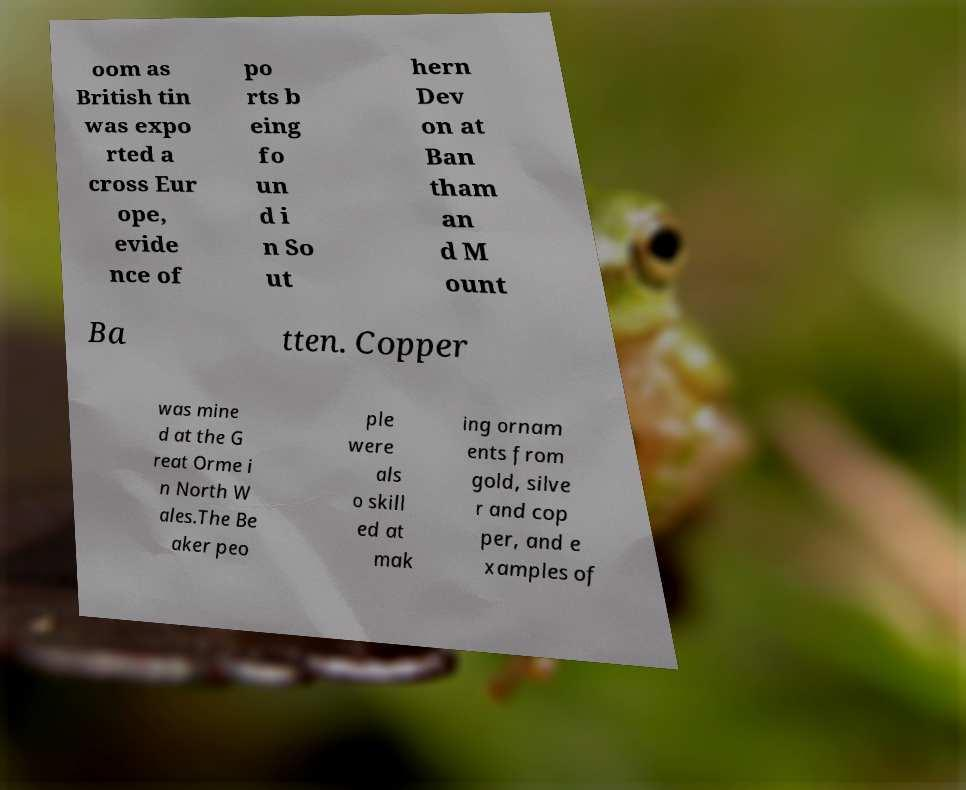There's text embedded in this image that I need extracted. Can you transcribe it verbatim? oom as British tin was expo rted a cross Eur ope, evide nce of po rts b eing fo un d i n So ut hern Dev on at Ban tham an d M ount Ba tten. Copper was mine d at the G reat Orme i n North W ales.The Be aker peo ple were als o skill ed at mak ing ornam ents from gold, silve r and cop per, and e xamples of 